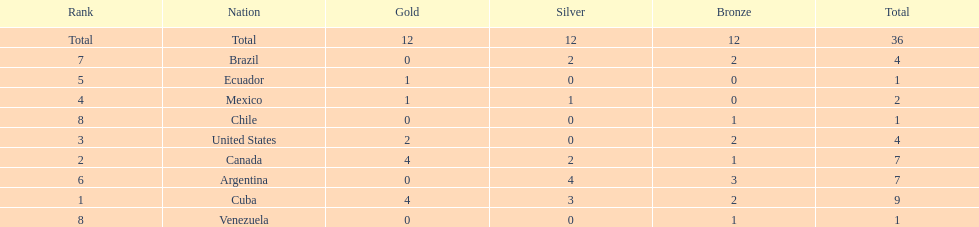Which is the only nation to win a gold medal and nothing else? Ecuador. Write the full table. {'header': ['Rank', 'Nation', 'Gold', 'Silver', 'Bronze', 'Total'], 'rows': [['Total', 'Total', '12', '12', '12', '36'], ['7', 'Brazil', '0', '2', '2', '4'], ['5', 'Ecuador', '1', '0', '0', '1'], ['4', 'Mexico', '1', '1', '0', '2'], ['8', 'Chile', '0', '0', '1', '1'], ['3', 'United States', '2', '0', '2', '4'], ['2', 'Canada', '4', '2', '1', '7'], ['6', 'Argentina', '0', '4', '3', '7'], ['1', 'Cuba', '4', '3', '2', '9'], ['8', 'Venezuela', '0', '0', '1', '1']]} 